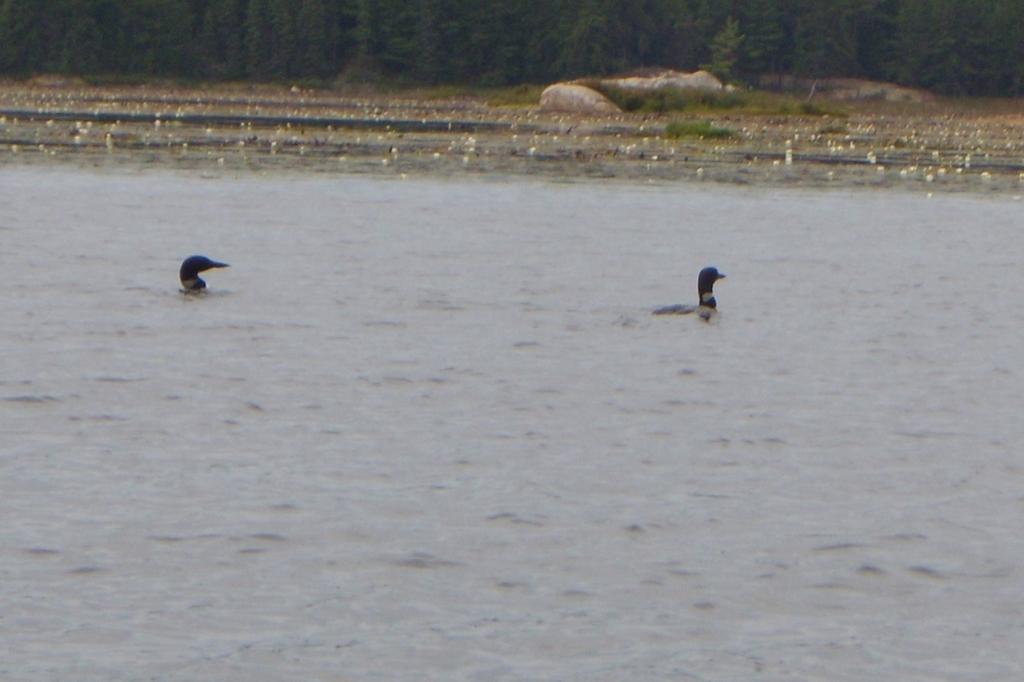What animals can be seen in the water in the foreground area? There are ducks in the water in the foreground area. What type of vegetation is present in the image? There are trees in the image. What other objects can be seen in the image? There are stones in the image. What month is it in the image? The month cannot be determined from the image, as there is no information about the time of year. 